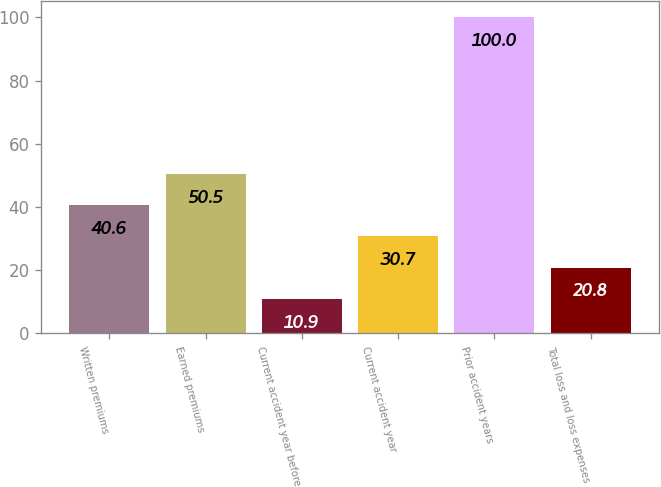<chart> <loc_0><loc_0><loc_500><loc_500><bar_chart><fcel>Written premiums<fcel>Earned premiums<fcel>Current accident year before<fcel>Current accident year<fcel>Prior accident years<fcel>Total loss and loss expenses<nl><fcel>40.6<fcel>50.5<fcel>10.9<fcel>30.7<fcel>100<fcel>20.8<nl></chart> 